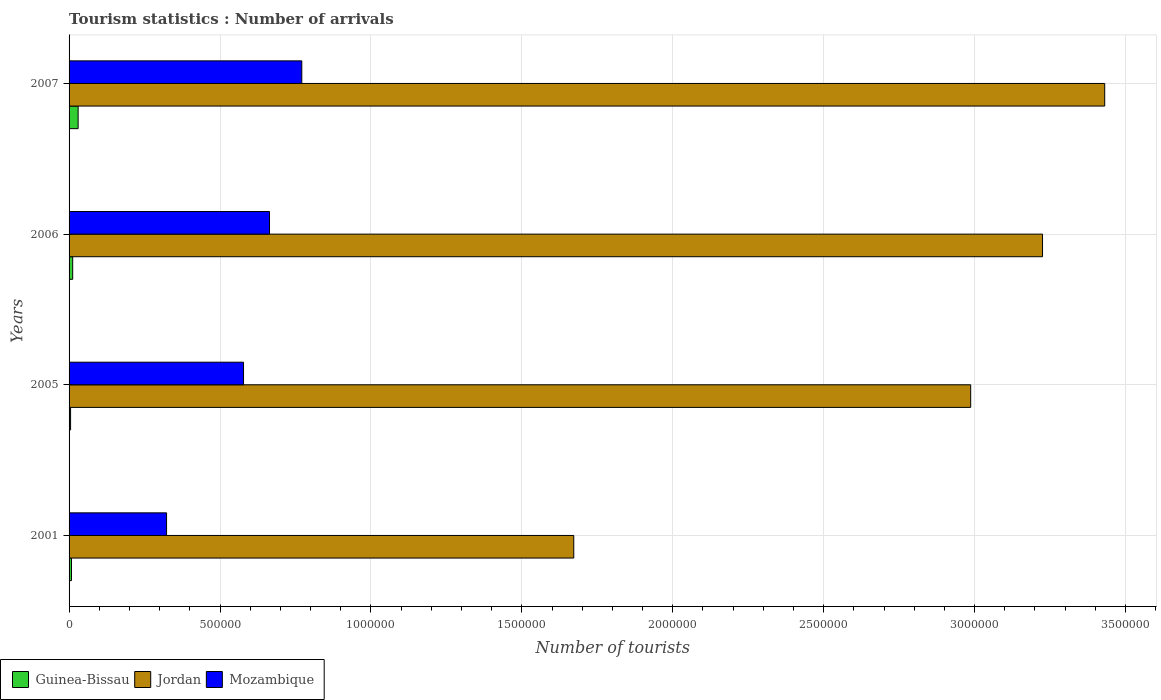How many groups of bars are there?
Provide a succinct answer. 4. Are the number of bars per tick equal to the number of legend labels?
Your answer should be very brief. Yes. Are the number of bars on each tick of the Y-axis equal?
Offer a very short reply. Yes. How many bars are there on the 3rd tick from the top?
Offer a very short reply. 3. How many bars are there on the 1st tick from the bottom?
Your answer should be compact. 3. What is the label of the 1st group of bars from the top?
Your answer should be compact. 2007. In how many cases, is the number of bars for a given year not equal to the number of legend labels?
Ensure brevity in your answer.  0. What is the number of tourist arrivals in Guinea-Bissau in 2001?
Make the answer very short. 8000. Across all years, what is the minimum number of tourist arrivals in Mozambique?
Provide a short and direct response. 3.23e+05. What is the total number of tourist arrivals in Guinea-Bissau in the graph?
Give a very brief answer. 5.50e+04. What is the difference between the number of tourist arrivals in Guinea-Bissau in 2001 and that in 2006?
Keep it short and to the point. -4000. What is the difference between the number of tourist arrivals in Guinea-Bissau in 2006 and the number of tourist arrivals in Jordan in 2005?
Your response must be concise. -2.98e+06. What is the average number of tourist arrivals in Mozambique per year?
Your response must be concise. 5.84e+05. In the year 2007, what is the difference between the number of tourist arrivals in Mozambique and number of tourist arrivals in Guinea-Bissau?
Your response must be concise. 7.41e+05. In how many years, is the number of tourist arrivals in Jordan greater than 3100000 ?
Ensure brevity in your answer.  2. What is the ratio of the number of tourist arrivals in Jordan in 2001 to that in 2006?
Your answer should be very brief. 0.52. What is the difference between the highest and the second highest number of tourist arrivals in Guinea-Bissau?
Offer a very short reply. 1.80e+04. What is the difference between the highest and the lowest number of tourist arrivals in Jordan?
Offer a very short reply. 1.76e+06. In how many years, is the number of tourist arrivals in Mozambique greater than the average number of tourist arrivals in Mozambique taken over all years?
Provide a short and direct response. 2. What does the 3rd bar from the top in 2007 represents?
Your response must be concise. Guinea-Bissau. What does the 3rd bar from the bottom in 2001 represents?
Give a very brief answer. Mozambique. How many years are there in the graph?
Your answer should be very brief. 4. What is the difference between two consecutive major ticks on the X-axis?
Make the answer very short. 5.00e+05. Are the values on the major ticks of X-axis written in scientific E-notation?
Offer a terse response. No. Where does the legend appear in the graph?
Your answer should be compact. Bottom left. How many legend labels are there?
Offer a very short reply. 3. How are the legend labels stacked?
Provide a short and direct response. Horizontal. What is the title of the graph?
Your answer should be very brief. Tourism statistics : Number of arrivals. What is the label or title of the X-axis?
Your answer should be very brief. Number of tourists. What is the label or title of the Y-axis?
Provide a succinct answer. Years. What is the Number of tourists of Guinea-Bissau in 2001?
Offer a terse response. 8000. What is the Number of tourists of Jordan in 2001?
Keep it short and to the point. 1.67e+06. What is the Number of tourists of Mozambique in 2001?
Offer a terse response. 3.23e+05. What is the Number of tourists in Jordan in 2005?
Your answer should be very brief. 2.99e+06. What is the Number of tourists of Mozambique in 2005?
Make the answer very short. 5.78e+05. What is the Number of tourists of Guinea-Bissau in 2006?
Provide a succinct answer. 1.20e+04. What is the Number of tourists in Jordan in 2006?
Provide a short and direct response. 3.22e+06. What is the Number of tourists of Mozambique in 2006?
Provide a short and direct response. 6.64e+05. What is the Number of tourists of Guinea-Bissau in 2007?
Keep it short and to the point. 3.00e+04. What is the Number of tourists of Jordan in 2007?
Make the answer very short. 3.43e+06. What is the Number of tourists of Mozambique in 2007?
Ensure brevity in your answer.  7.71e+05. Across all years, what is the maximum Number of tourists of Jordan?
Your answer should be compact. 3.43e+06. Across all years, what is the maximum Number of tourists of Mozambique?
Your answer should be very brief. 7.71e+05. Across all years, what is the minimum Number of tourists in Jordan?
Ensure brevity in your answer.  1.67e+06. Across all years, what is the minimum Number of tourists in Mozambique?
Your answer should be compact. 3.23e+05. What is the total Number of tourists of Guinea-Bissau in the graph?
Provide a short and direct response. 5.50e+04. What is the total Number of tourists in Jordan in the graph?
Keep it short and to the point. 1.13e+07. What is the total Number of tourists in Mozambique in the graph?
Your response must be concise. 2.34e+06. What is the difference between the Number of tourists of Guinea-Bissau in 2001 and that in 2005?
Ensure brevity in your answer.  3000. What is the difference between the Number of tourists in Jordan in 2001 and that in 2005?
Ensure brevity in your answer.  -1.32e+06. What is the difference between the Number of tourists of Mozambique in 2001 and that in 2005?
Your response must be concise. -2.55e+05. What is the difference between the Number of tourists of Guinea-Bissau in 2001 and that in 2006?
Offer a terse response. -4000. What is the difference between the Number of tourists in Jordan in 2001 and that in 2006?
Provide a short and direct response. -1.55e+06. What is the difference between the Number of tourists of Mozambique in 2001 and that in 2006?
Your answer should be compact. -3.41e+05. What is the difference between the Number of tourists of Guinea-Bissau in 2001 and that in 2007?
Your answer should be compact. -2.20e+04. What is the difference between the Number of tourists in Jordan in 2001 and that in 2007?
Give a very brief answer. -1.76e+06. What is the difference between the Number of tourists in Mozambique in 2001 and that in 2007?
Provide a succinct answer. -4.48e+05. What is the difference between the Number of tourists in Guinea-Bissau in 2005 and that in 2006?
Ensure brevity in your answer.  -7000. What is the difference between the Number of tourists of Jordan in 2005 and that in 2006?
Make the answer very short. -2.38e+05. What is the difference between the Number of tourists in Mozambique in 2005 and that in 2006?
Your answer should be compact. -8.60e+04. What is the difference between the Number of tourists in Guinea-Bissau in 2005 and that in 2007?
Make the answer very short. -2.50e+04. What is the difference between the Number of tourists in Jordan in 2005 and that in 2007?
Your answer should be compact. -4.44e+05. What is the difference between the Number of tourists of Mozambique in 2005 and that in 2007?
Provide a short and direct response. -1.93e+05. What is the difference between the Number of tourists of Guinea-Bissau in 2006 and that in 2007?
Your answer should be compact. -1.80e+04. What is the difference between the Number of tourists in Jordan in 2006 and that in 2007?
Offer a terse response. -2.06e+05. What is the difference between the Number of tourists in Mozambique in 2006 and that in 2007?
Provide a short and direct response. -1.07e+05. What is the difference between the Number of tourists of Guinea-Bissau in 2001 and the Number of tourists of Jordan in 2005?
Offer a terse response. -2.98e+06. What is the difference between the Number of tourists of Guinea-Bissau in 2001 and the Number of tourists of Mozambique in 2005?
Provide a short and direct response. -5.70e+05. What is the difference between the Number of tourists of Jordan in 2001 and the Number of tourists of Mozambique in 2005?
Keep it short and to the point. 1.09e+06. What is the difference between the Number of tourists of Guinea-Bissau in 2001 and the Number of tourists of Jordan in 2006?
Offer a very short reply. -3.22e+06. What is the difference between the Number of tourists of Guinea-Bissau in 2001 and the Number of tourists of Mozambique in 2006?
Your response must be concise. -6.56e+05. What is the difference between the Number of tourists of Jordan in 2001 and the Number of tourists of Mozambique in 2006?
Make the answer very short. 1.01e+06. What is the difference between the Number of tourists in Guinea-Bissau in 2001 and the Number of tourists in Jordan in 2007?
Make the answer very short. -3.42e+06. What is the difference between the Number of tourists in Guinea-Bissau in 2001 and the Number of tourists in Mozambique in 2007?
Your answer should be compact. -7.63e+05. What is the difference between the Number of tourists in Jordan in 2001 and the Number of tourists in Mozambique in 2007?
Make the answer very short. 9.01e+05. What is the difference between the Number of tourists of Guinea-Bissau in 2005 and the Number of tourists of Jordan in 2006?
Offer a terse response. -3.22e+06. What is the difference between the Number of tourists of Guinea-Bissau in 2005 and the Number of tourists of Mozambique in 2006?
Your response must be concise. -6.59e+05. What is the difference between the Number of tourists of Jordan in 2005 and the Number of tourists of Mozambique in 2006?
Your answer should be compact. 2.32e+06. What is the difference between the Number of tourists in Guinea-Bissau in 2005 and the Number of tourists in Jordan in 2007?
Provide a short and direct response. -3.43e+06. What is the difference between the Number of tourists of Guinea-Bissau in 2005 and the Number of tourists of Mozambique in 2007?
Your response must be concise. -7.66e+05. What is the difference between the Number of tourists of Jordan in 2005 and the Number of tourists of Mozambique in 2007?
Keep it short and to the point. 2.22e+06. What is the difference between the Number of tourists in Guinea-Bissau in 2006 and the Number of tourists in Jordan in 2007?
Your answer should be very brief. -3.42e+06. What is the difference between the Number of tourists in Guinea-Bissau in 2006 and the Number of tourists in Mozambique in 2007?
Your response must be concise. -7.59e+05. What is the difference between the Number of tourists of Jordan in 2006 and the Number of tourists of Mozambique in 2007?
Make the answer very short. 2.45e+06. What is the average Number of tourists of Guinea-Bissau per year?
Your answer should be very brief. 1.38e+04. What is the average Number of tourists in Jordan per year?
Give a very brief answer. 2.83e+06. What is the average Number of tourists of Mozambique per year?
Your answer should be compact. 5.84e+05. In the year 2001, what is the difference between the Number of tourists in Guinea-Bissau and Number of tourists in Jordan?
Make the answer very short. -1.66e+06. In the year 2001, what is the difference between the Number of tourists in Guinea-Bissau and Number of tourists in Mozambique?
Ensure brevity in your answer.  -3.15e+05. In the year 2001, what is the difference between the Number of tourists of Jordan and Number of tourists of Mozambique?
Offer a terse response. 1.35e+06. In the year 2005, what is the difference between the Number of tourists of Guinea-Bissau and Number of tourists of Jordan?
Provide a succinct answer. -2.98e+06. In the year 2005, what is the difference between the Number of tourists in Guinea-Bissau and Number of tourists in Mozambique?
Offer a very short reply. -5.73e+05. In the year 2005, what is the difference between the Number of tourists of Jordan and Number of tourists of Mozambique?
Keep it short and to the point. 2.41e+06. In the year 2006, what is the difference between the Number of tourists of Guinea-Bissau and Number of tourists of Jordan?
Provide a short and direct response. -3.21e+06. In the year 2006, what is the difference between the Number of tourists of Guinea-Bissau and Number of tourists of Mozambique?
Ensure brevity in your answer.  -6.52e+05. In the year 2006, what is the difference between the Number of tourists in Jordan and Number of tourists in Mozambique?
Provide a succinct answer. 2.56e+06. In the year 2007, what is the difference between the Number of tourists in Guinea-Bissau and Number of tourists in Jordan?
Make the answer very short. -3.40e+06. In the year 2007, what is the difference between the Number of tourists of Guinea-Bissau and Number of tourists of Mozambique?
Keep it short and to the point. -7.41e+05. In the year 2007, what is the difference between the Number of tourists in Jordan and Number of tourists in Mozambique?
Make the answer very short. 2.66e+06. What is the ratio of the Number of tourists in Guinea-Bissau in 2001 to that in 2005?
Offer a terse response. 1.6. What is the ratio of the Number of tourists in Jordan in 2001 to that in 2005?
Keep it short and to the point. 0.56. What is the ratio of the Number of tourists of Mozambique in 2001 to that in 2005?
Offer a very short reply. 0.56. What is the ratio of the Number of tourists of Guinea-Bissau in 2001 to that in 2006?
Keep it short and to the point. 0.67. What is the ratio of the Number of tourists of Jordan in 2001 to that in 2006?
Offer a very short reply. 0.52. What is the ratio of the Number of tourists in Mozambique in 2001 to that in 2006?
Provide a short and direct response. 0.49. What is the ratio of the Number of tourists of Guinea-Bissau in 2001 to that in 2007?
Give a very brief answer. 0.27. What is the ratio of the Number of tourists of Jordan in 2001 to that in 2007?
Offer a terse response. 0.49. What is the ratio of the Number of tourists in Mozambique in 2001 to that in 2007?
Give a very brief answer. 0.42. What is the ratio of the Number of tourists in Guinea-Bissau in 2005 to that in 2006?
Offer a terse response. 0.42. What is the ratio of the Number of tourists of Jordan in 2005 to that in 2006?
Provide a short and direct response. 0.93. What is the ratio of the Number of tourists of Mozambique in 2005 to that in 2006?
Offer a terse response. 0.87. What is the ratio of the Number of tourists in Jordan in 2005 to that in 2007?
Your response must be concise. 0.87. What is the ratio of the Number of tourists of Mozambique in 2005 to that in 2007?
Make the answer very short. 0.75. What is the ratio of the Number of tourists in Guinea-Bissau in 2006 to that in 2007?
Provide a short and direct response. 0.4. What is the ratio of the Number of tourists of Mozambique in 2006 to that in 2007?
Give a very brief answer. 0.86. What is the difference between the highest and the second highest Number of tourists in Guinea-Bissau?
Offer a terse response. 1.80e+04. What is the difference between the highest and the second highest Number of tourists in Jordan?
Offer a very short reply. 2.06e+05. What is the difference between the highest and the second highest Number of tourists in Mozambique?
Make the answer very short. 1.07e+05. What is the difference between the highest and the lowest Number of tourists in Guinea-Bissau?
Your answer should be very brief. 2.50e+04. What is the difference between the highest and the lowest Number of tourists of Jordan?
Your answer should be compact. 1.76e+06. What is the difference between the highest and the lowest Number of tourists of Mozambique?
Your response must be concise. 4.48e+05. 